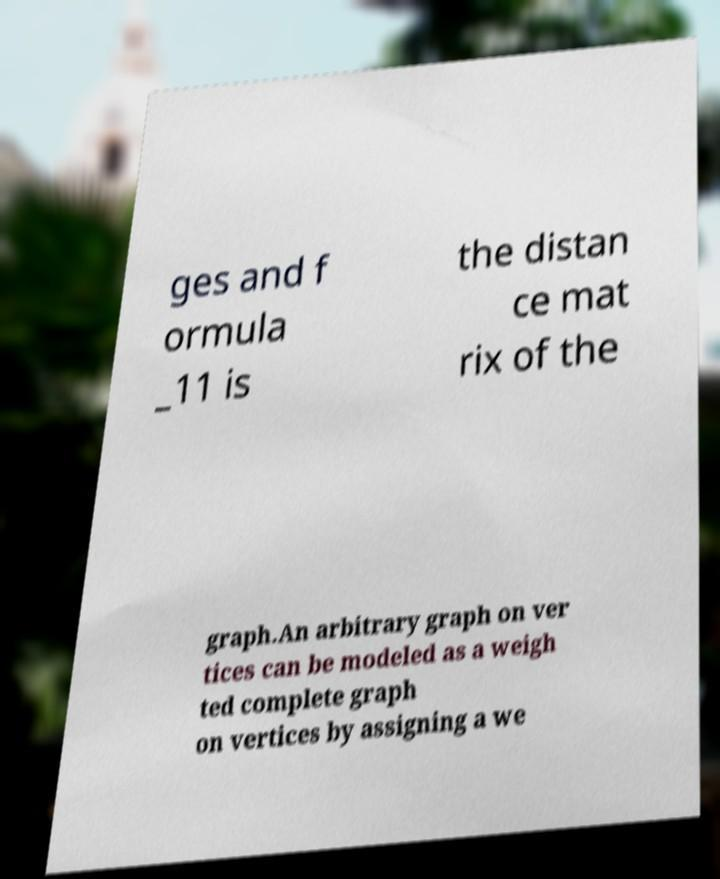Please read and relay the text visible in this image. What does it say? ges and f ormula _11 is the distan ce mat rix of the graph.An arbitrary graph on ver tices can be modeled as a weigh ted complete graph on vertices by assigning a we 